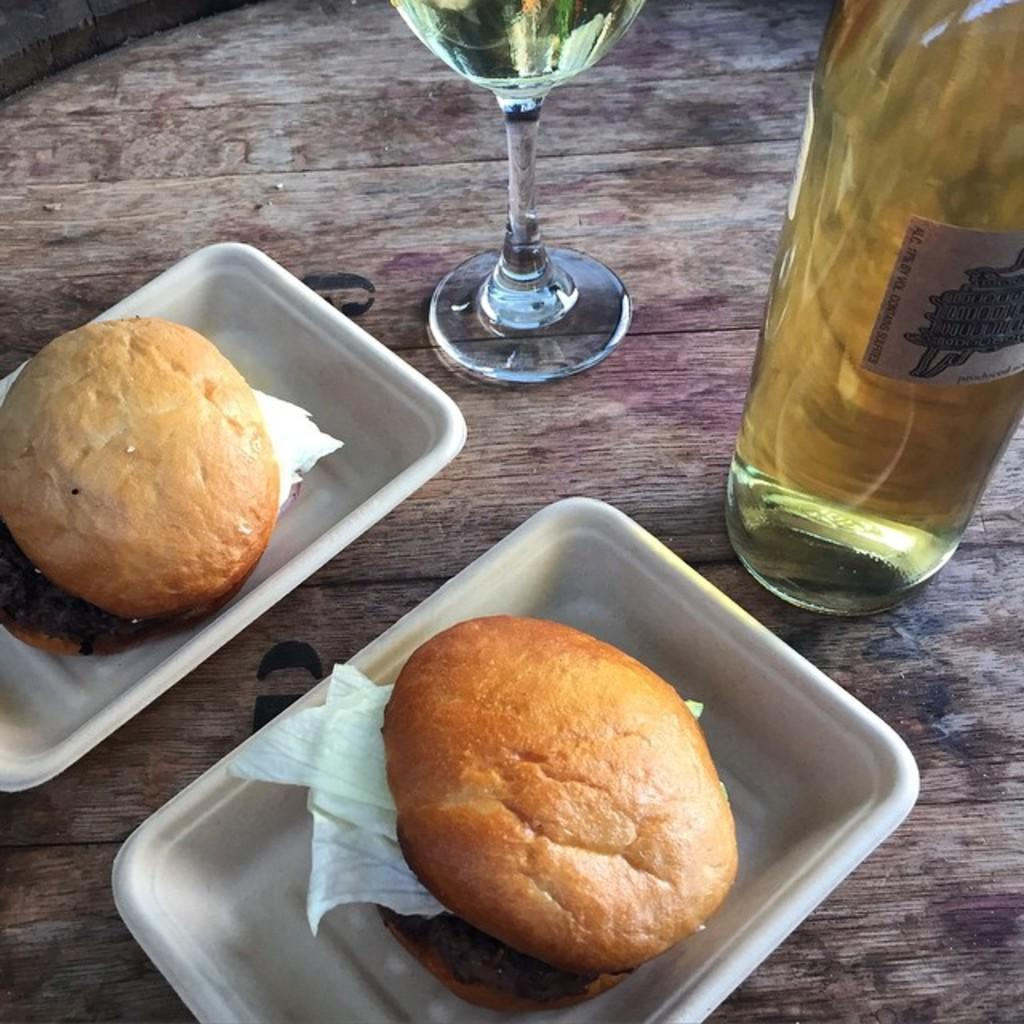What type of table is in the image? There is a wooden table in the image. How many bowls are on the table? There are 2 bowls on the table. What is inside the bowls? The bowls contain burgers. What else can be seen on the table? There is a glass bottle and a glass of drink in the image. What type of peace is being promoted in the image? There is no reference to peace or any promotion of peace in the image. 